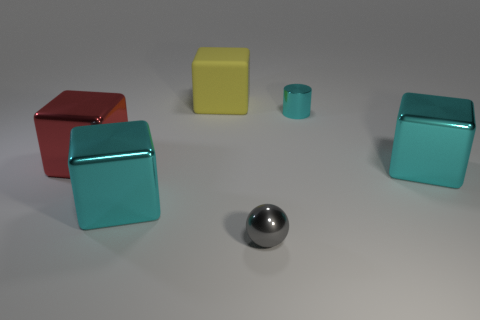Subtract 1 cubes. How many cubes are left? 3 Add 3 small cyan cylinders. How many objects exist? 9 Subtract all spheres. How many objects are left? 5 Add 4 small cyan cylinders. How many small cyan cylinders are left? 5 Add 2 cyan shiny things. How many cyan shiny things exist? 5 Subtract 0 purple balls. How many objects are left? 6 Subtract all large metallic blocks. Subtract all cyan things. How many objects are left? 0 